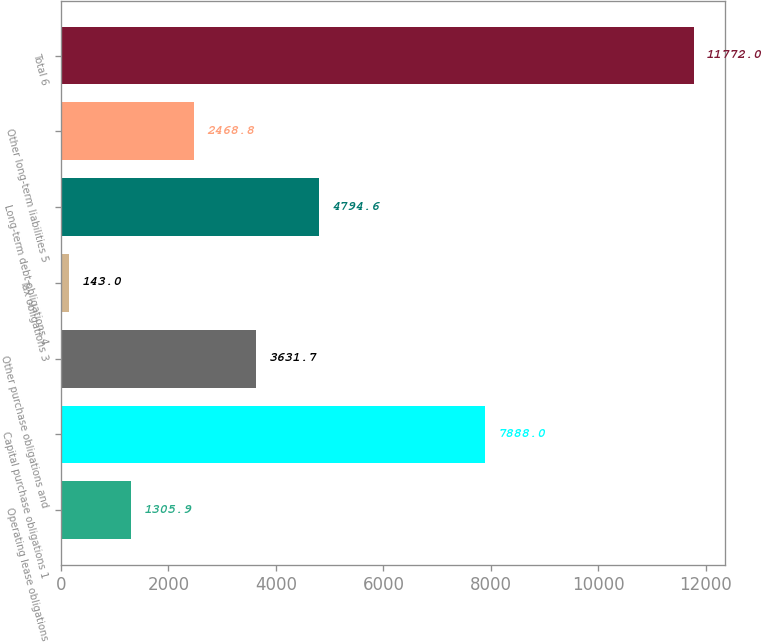<chart> <loc_0><loc_0><loc_500><loc_500><bar_chart><fcel>Operating lease obligations<fcel>Capital purchase obligations 1<fcel>Other purchase obligations and<fcel>Tax obligations 3<fcel>Long-term debt obligations 4<fcel>Other long-term liabilities 5<fcel>Total 6<nl><fcel>1305.9<fcel>7888<fcel>3631.7<fcel>143<fcel>4794.6<fcel>2468.8<fcel>11772<nl></chart> 